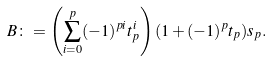<formula> <loc_0><loc_0><loc_500><loc_500>B \colon = \left ( \sum _ { i = 0 } ^ { p } ( - 1 ) ^ { p i } t ^ { i } _ { p } \right ) ( 1 + ( - 1 ) ^ { p } t _ { p } ) s _ { p } .</formula> 